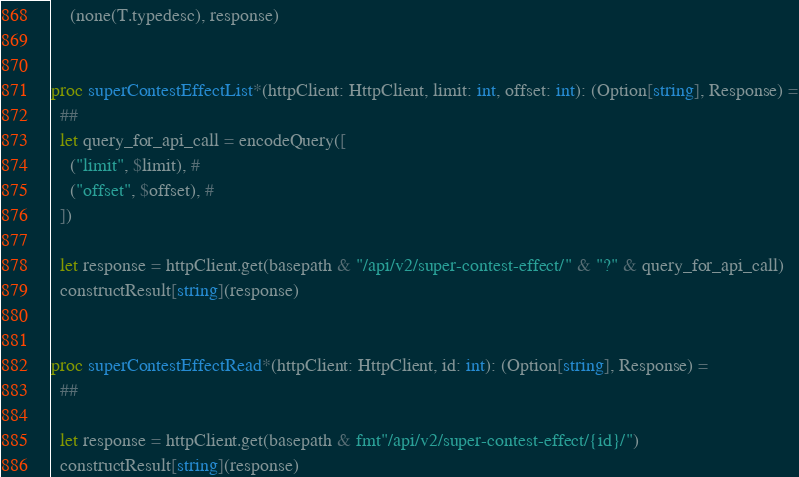Convert code to text. <code><loc_0><loc_0><loc_500><loc_500><_Nim_>    (none(T.typedesc), response)


proc superContestEffectList*(httpClient: HttpClient, limit: int, offset: int): (Option[string], Response) =
  ## 
  let query_for_api_call = encodeQuery([
    ("limit", $limit), # 
    ("offset", $offset), # 
  ])

  let response = httpClient.get(basepath & "/api/v2/super-contest-effect/" & "?" & query_for_api_call)
  constructResult[string](response)


proc superContestEffectRead*(httpClient: HttpClient, id: int): (Option[string], Response) =
  ## 

  let response = httpClient.get(basepath & fmt"/api/v2/super-contest-effect/{id}/")
  constructResult[string](response)

</code> 